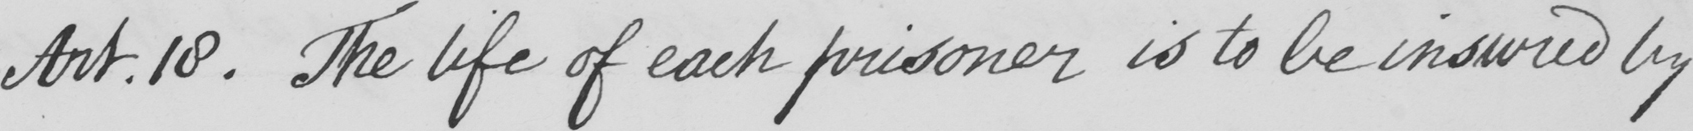What does this handwritten line say? Art . 18 . The life of each prisoner is to be insured by 